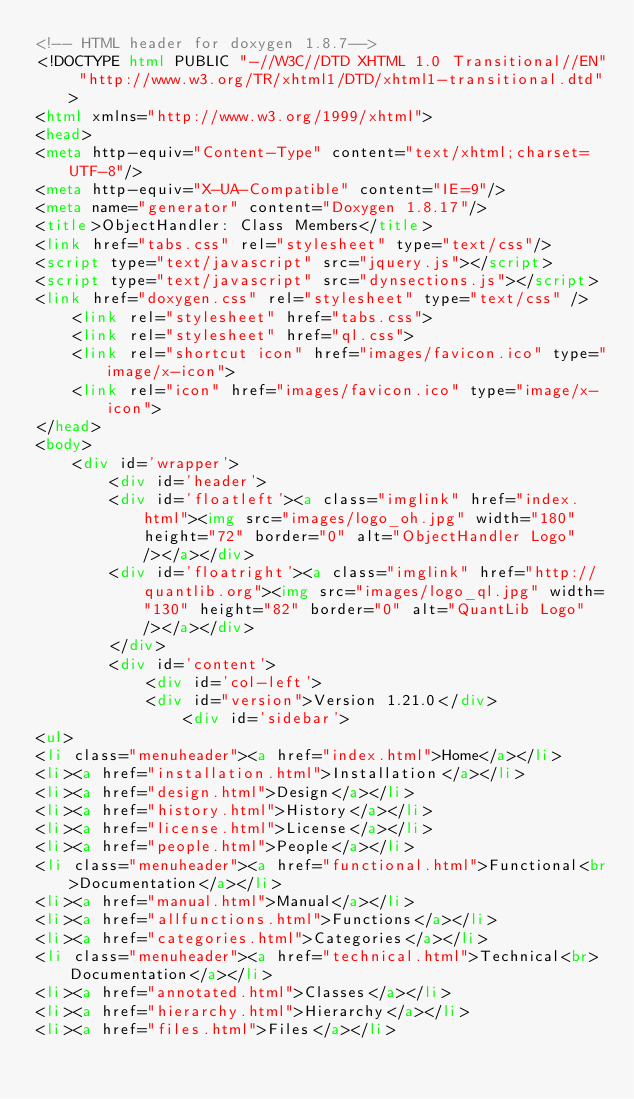Convert code to text. <code><loc_0><loc_0><loc_500><loc_500><_HTML_><!-- HTML header for doxygen 1.8.7-->
<!DOCTYPE html PUBLIC "-//W3C//DTD XHTML 1.0 Transitional//EN" "http://www.w3.org/TR/xhtml1/DTD/xhtml1-transitional.dtd">
<html xmlns="http://www.w3.org/1999/xhtml">
<head>
<meta http-equiv="Content-Type" content="text/xhtml;charset=UTF-8"/>
<meta http-equiv="X-UA-Compatible" content="IE=9"/>
<meta name="generator" content="Doxygen 1.8.17"/>
<title>ObjectHandler: Class Members</title>
<link href="tabs.css" rel="stylesheet" type="text/css"/>
<script type="text/javascript" src="jquery.js"></script>
<script type="text/javascript" src="dynsections.js"></script>
<link href="doxygen.css" rel="stylesheet" type="text/css" />
    <link rel="stylesheet" href="tabs.css">
    <link rel="stylesheet" href="ql.css">
    <link rel="shortcut icon" href="images/favicon.ico" type="image/x-icon">
    <link rel="icon" href="images/favicon.ico" type="image/x-icon">
</head>
<body>
    <div id='wrapper'>
        <div id='header'>
        <div id='floatleft'><a class="imglink" href="index.html"><img src="images/logo_oh.jpg" width="180" height="72" border="0" alt="ObjectHandler Logo"/></a></div>
        <div id='floatright'><a class="imglink" href="http://quantlib.org"><img src="images/logo_ql.jpg" width="130" height="82" border="0" alt="QuantLib Logo"/></a></div>
        </div>
        <div id='content'>
            <div id='col-left'>
            <div id="version">Version 1.21.0</div>
                <div id='sidebar'>
<ul>
<li class="menuheader"><a href="index.html">Home</a></li>
<li><a href="installation.html">Installation</a></li>
<li><a href="design.html">Design</a></li>
<li><a href="history.html">History</a></li>
<li><a href="license.html">License</a></li>
<li><a href="people.html">People</a></li>
<li class="menuheader"><a href="functional.html">Functional<br>Documentation</a></li>
<li><a href="manual.html">Manual</a></li>
<li><a href="allfunctions.html">Functions</a></li>
<li><a href="categories.html">Categories</a></li>
<li class="menuheader"><a href="technical.html">Technical<br>Documentation</a></li>
<li><a href="annotated.html">Classes</a></li>
<li><a href="hierarchy.html">Hierarchy</a></li>
<li><a href="files.html">Files</a></li></code> 